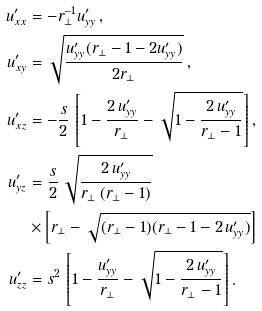<formula> <loc_0><loc_0><loc_500><loc_500>u ^ { \prime } _ { x x } & = - r _ { \perp } ^ { - 1 } u ^ { \prime } _ { y y } \, , \\ u ^ { \prime } _ { x y } & = \sqrt { \frac { u ^ { \prime } _ { y y } ( r _ { \perp } - 1 - 2 u ^ { \prime } _ { y y } ) } { 2 r _ { \perp } } } \, , \\ u ^ { \prime } _ { x z } & = - \frac { s } { 2 } \, \left [ 1 - \frac { 2 \, u ^ { \prime } _ { y y } } { r _ { \perp } } - \sqrt { 1 - \frac { 2 \, u ^ { \prime } _ { y y } } { r _ { \perp } - 1 } } \right ] , \\ u ^ { \prime } _ { y z } & = \frac { s } { 2 } \, \sqrt { \frac { 2 \, u ^ { \prime } _ { y y } } { r _ { \perp } \, ( r _ { \perp } - 1 ) } } \\ & \times \left [ r _ { \perp } - \sqrt { ( r _ { \perp } - 1 ) ( r _ { \perp } - 1 - 2 \, u ^ { \prime } _ { y y } ) } \right ] \\ u ^ { \prime } _ { z z } & = s ^ { 2 } \, \left [ 1 - \frac { u ^ { \prime } _ { y y } } { r _ { \perp } } - \sqrt { 1 - \frac { 2 \, u ^ { \prime } _ { y y } } { r _ { \perp } - 1 } } \right ] .</formula> 